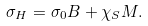<formula> <loc_0><loc_0><loc_500><loc_500>\sigma _ { H } = \sigma _ { 0 } B + \chi _ { S } M .</formula> 